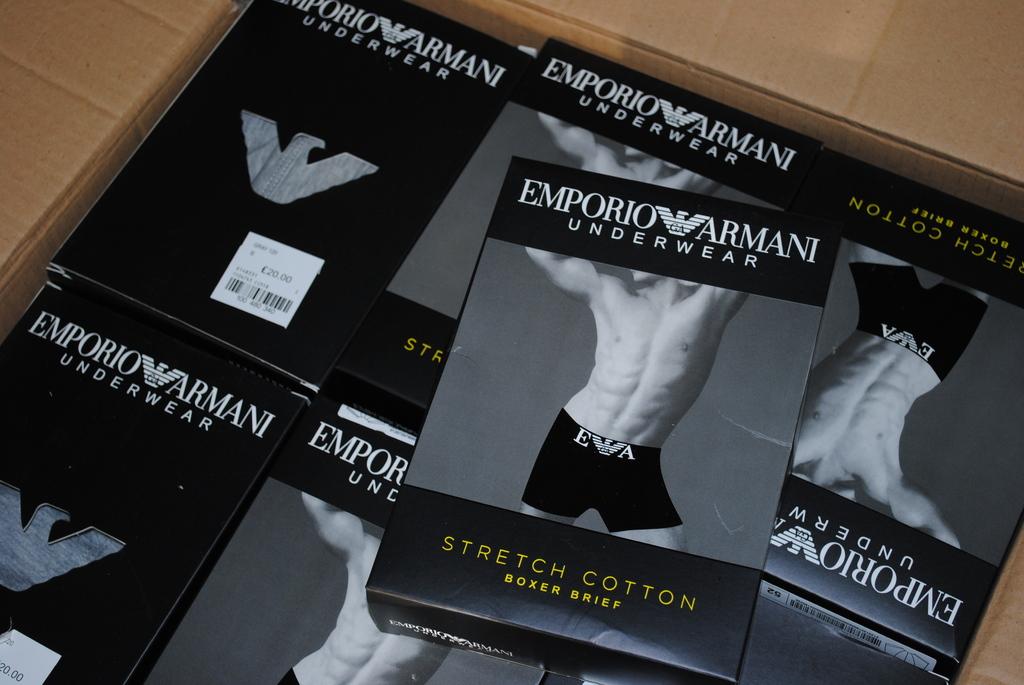What type of clothing is written on the box?
Your answer should be very brief. Underwear. 